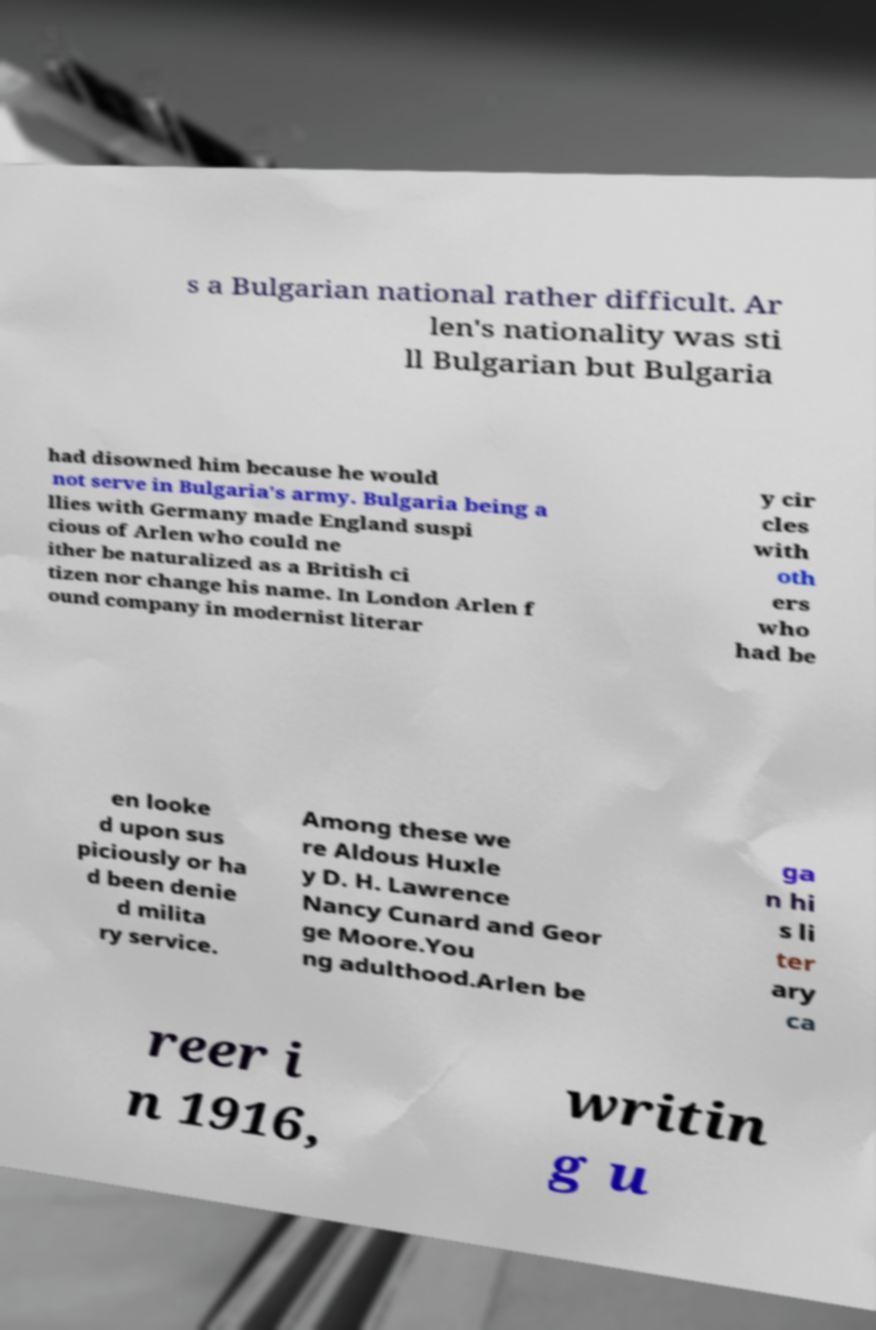Can you read and provide the text displayed in the image?This photo seems to have some interesting text. Can you extract and type it out for me? s a Bulgarian national rather difficult. Ar len's nationality was sti ll Bulgarian but Bulgaria had disowned him because he would not serve in Bulgaria's army. Bulgaria being a llies with Germany made England suspi cious of Arlen who could ne ither be naturalized as a British ci tizen nor change his name. In London Arlen f ound company in modernist literar y cir cles with oth ers who had be en looke d upon sus piciously or ha d been denie d milita ry service. Among these we re Aldous Huxle y D. H. Lawrence Nancy Cunard and Geor ge Moore.You ng adulthood.Arlen be ga n hi s li ter ary ca reer i n 1916, writin g u 